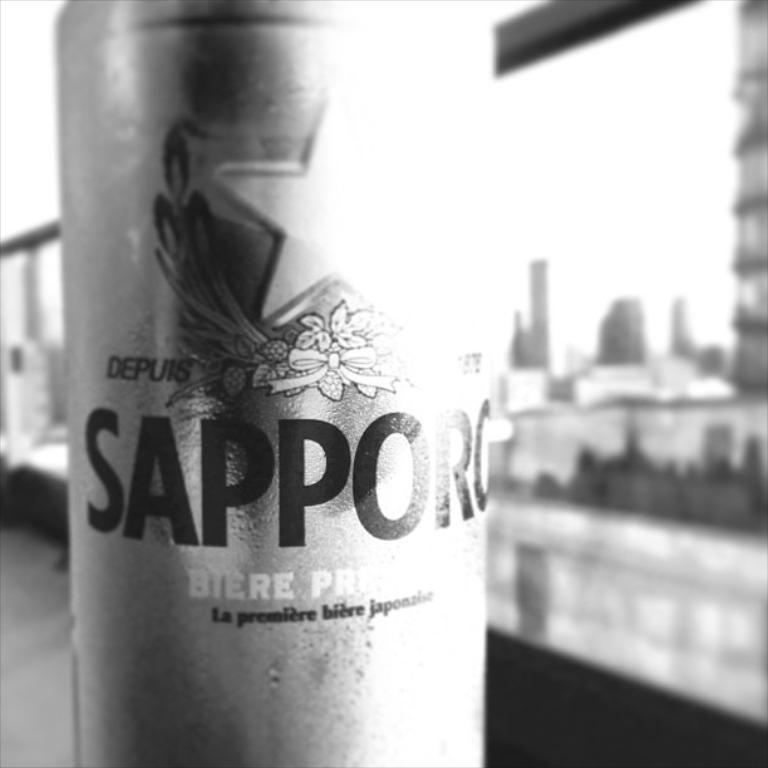What type of japanese beer is this?
Give a very brief answer. Sapporo. What is the brand of the beer?
Ensure brevity in your answer.  Sapporo. 